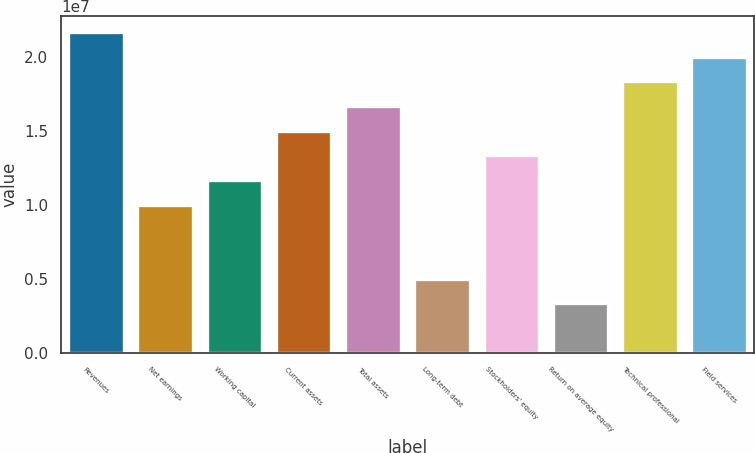Convert chart to OTSL. <chart><loc_0><loc_0><loc_500><loc_500><bar_chart><fcel>Revenues<fcel>Net earnings<fcel>Working capital<fcel>Current assets<fcel>Total assets<fcel>Long-term debt<fcel>Stockholders' equity<fcel>Return on average equity<fcel>Technical professional<fcel>Field services<nl><fcel>2.17056e+07<fcel>1.0018e+07<fcel>1.16876e+07<fcel>1.50269e+07<fcel>1.66966e+07<fcel>5.00898e+06<fcel>1.33573e+07<fcel>3.33932e+06<fcel>1.83663e+07<fcel>2.00359e+07<nl></chart> 